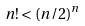Convert formula to latex. <formula><loc_0><loc_0><loc_500><loc_500>n ! < ( n / 2 ) ^ { n }</formula> 